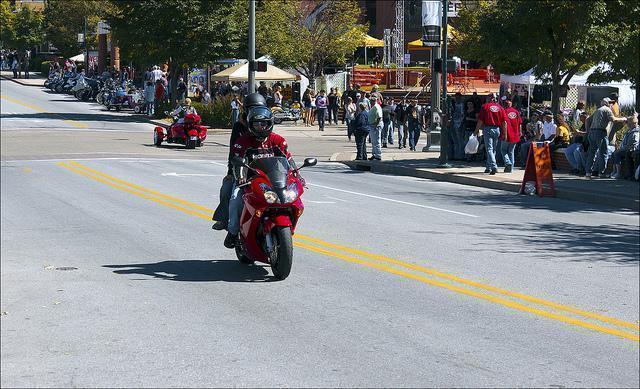What type of vehicles are most shown here?
Pick the correct solution from the four options below to address the question.
Options: Bicycles, trains, cars, motorcycles. Motorcycles. 